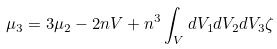Convert formula to latex. <formula><loc_0><loc_0><loc_500><loc_500>\mu _ { 3 } = 3 \mu _ { 2 } - 2 n V + n ^ { 3 } \int _ { V } d V _ { 1 } d V _ { 2 } d V _ { 3 } \zeta</formula> 